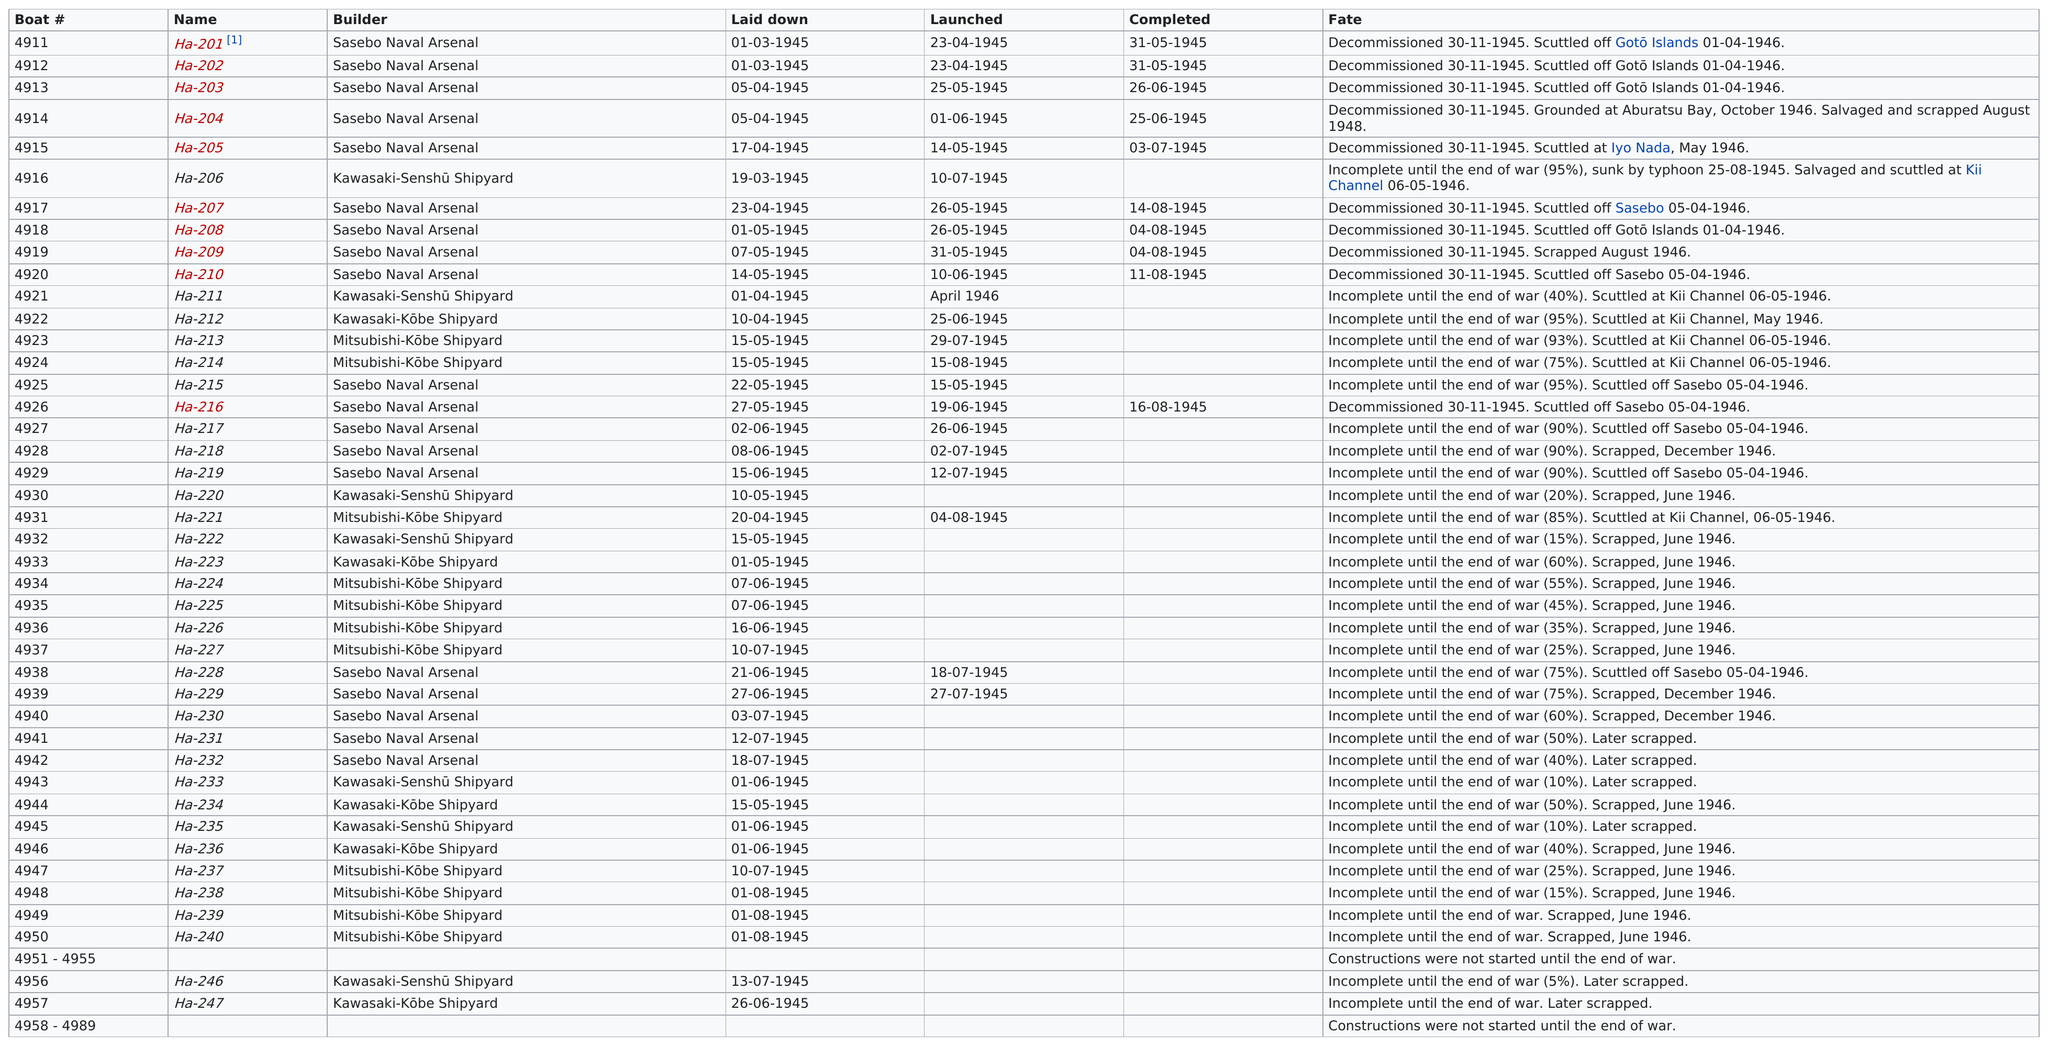Point out several critical features in this image. On the same day as HA-201, another boat was completed. That boat was HA-202. Four boats were scuttled off the Goto Islands. A boat was launched immediately before Ha-206, and Ha-218 occurred afterwards. The following boats were laid down after May 1945: Ha-217, Ha-218, Ha-219, Ha-224, Ha-225, Ha-226, Ha-227, Ha-228, Ha-229, Ha-230, Ha-231, Ha-232, Ha-233, Ha-235, Ha-236, Ha-237, Ha-238, Ha-239, Ha-240, Ha-246, Ha-247. On February 28th, 1945, the German submarine U-864 was scuttled due to extensive damage sustained during a naval battle. The exact isotopes of hafnium, either hafnium-206 or hafnium-208, were present on the submarine at the time of sinking. 